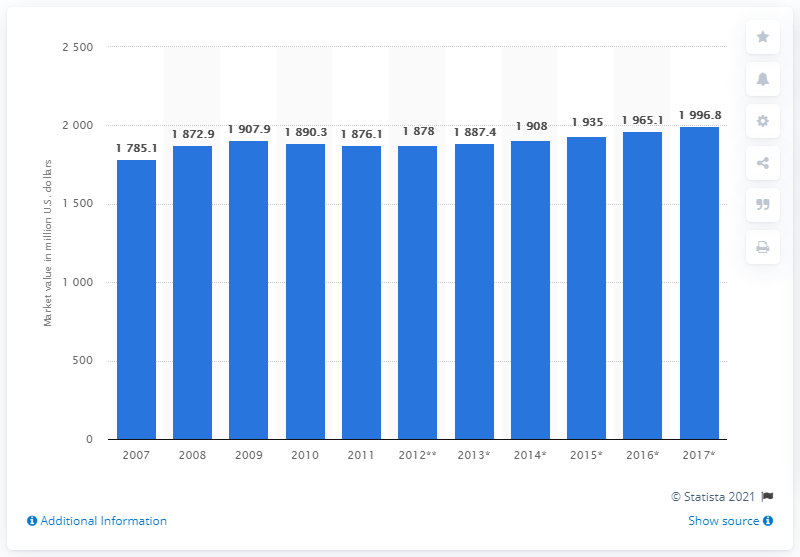Identify some key points in this picture. The market value of packaged organic food and beverages in the UK was in 2007. 